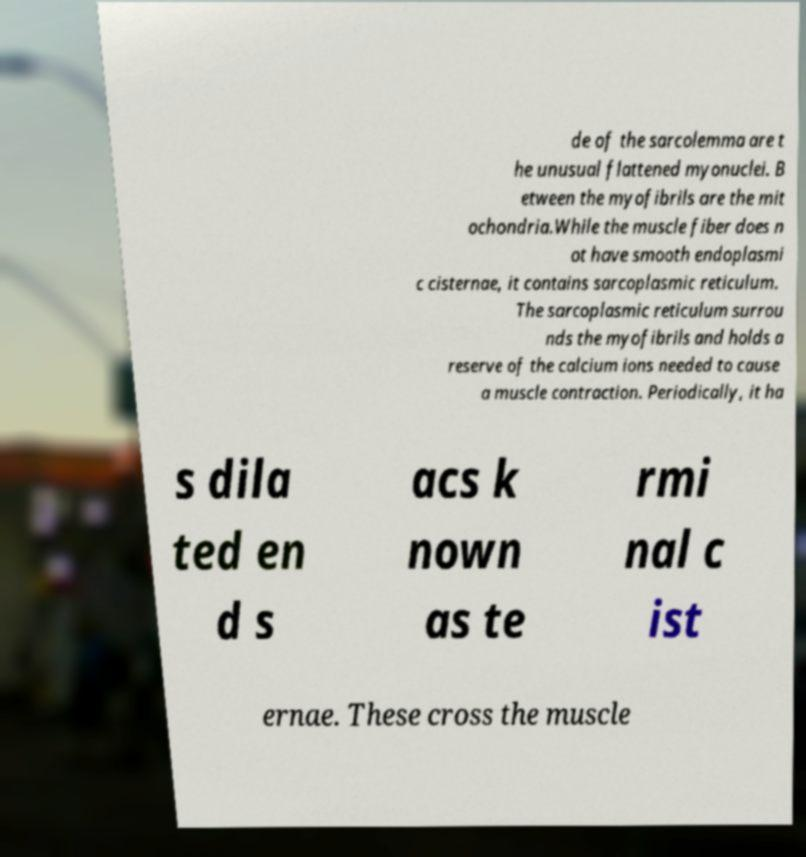Could you extract and type out the text from this image? de of the sarcolemma are t he unusual flattened myonuclei. B etween the myofibrils are the mit ochondria.While the muscle fiber does n ot have smooth endoplasmi c cisternae, it contains sarcoplasmic reticulum. The sarcoplasmic reticulum surrou nds the myofibrils and holds a reserve of the calcium ions needed to cause a muscle contraction. Periodically, it ha s dila ted en d s acs k nown as te rmi nal c ist ernae. These cross the muscle 